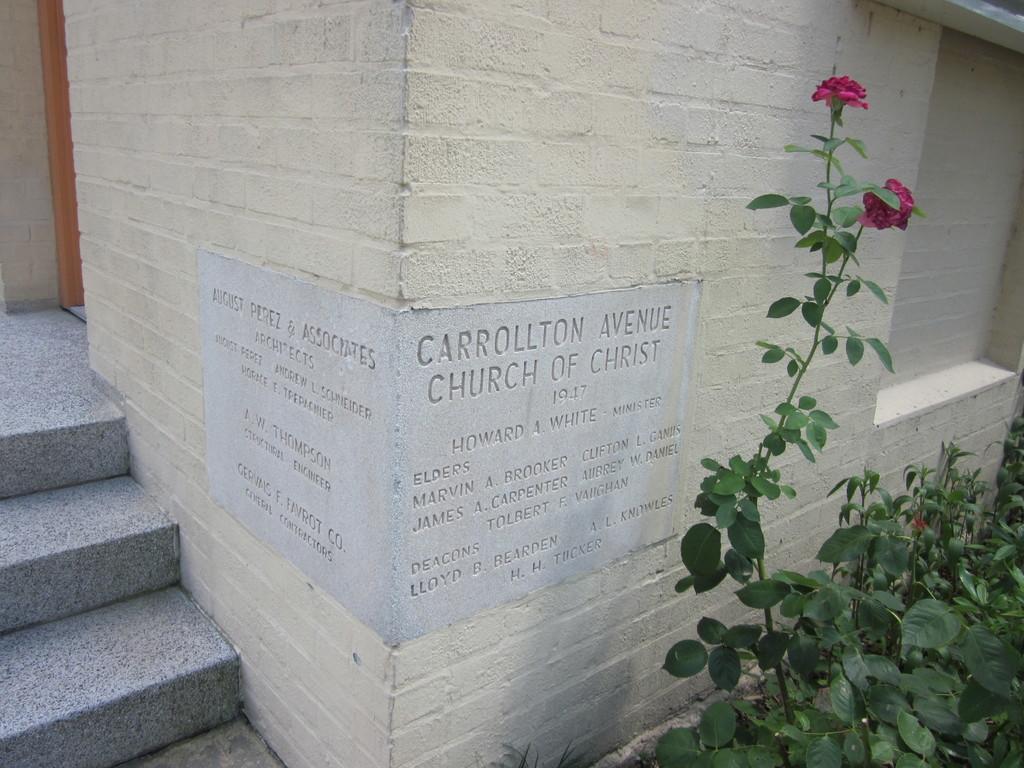In one or two sentences, can you explain what this image depicts? Here I can see a wall on which there is some text. On the right side there are few plants along with the flowers. On the left side there are stairs. 